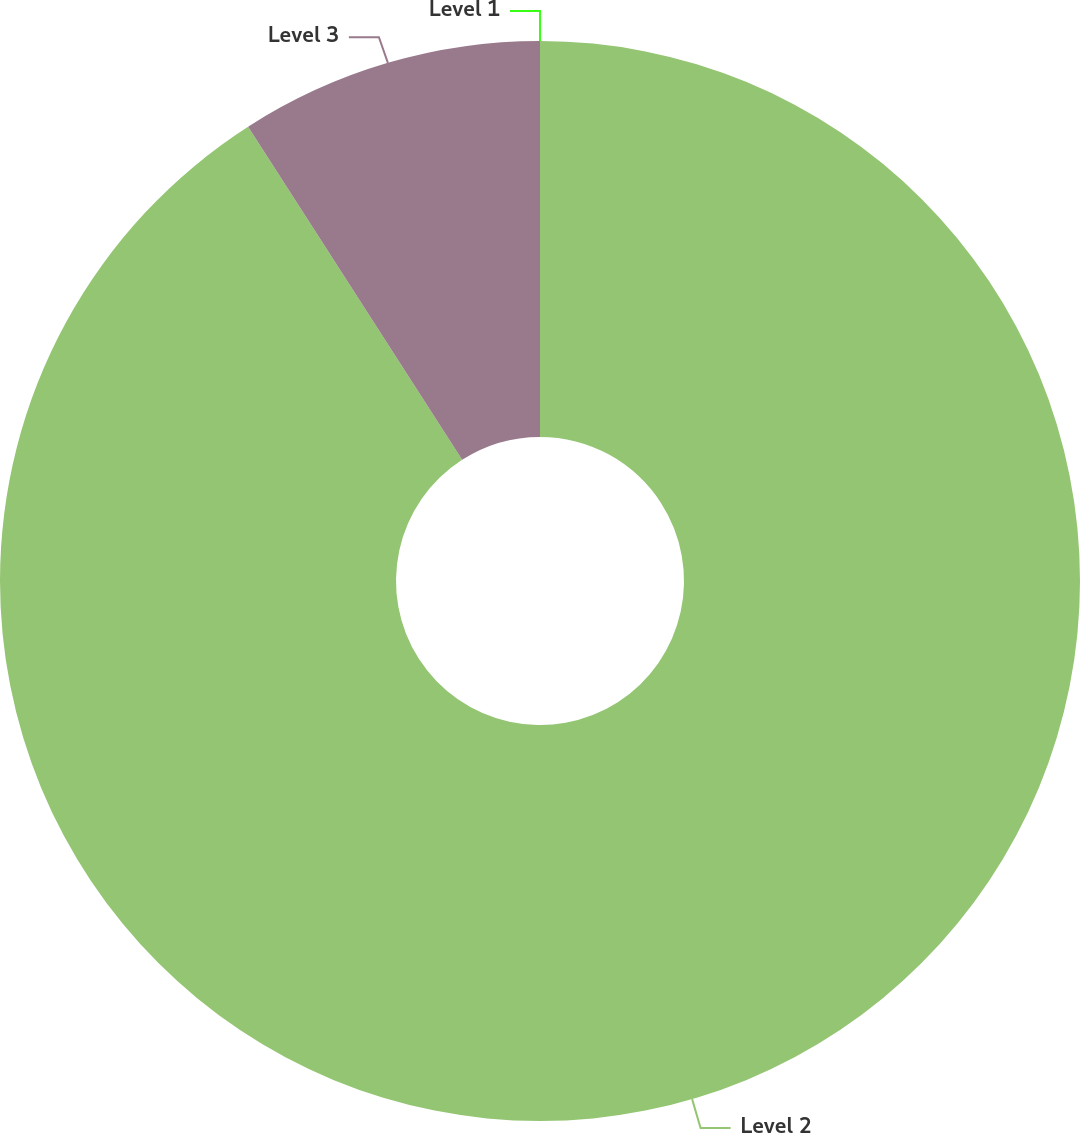<chart> <loc_0><loc_0><loc_500><loc_500><pie_chart><fcel>Level 1<fcel>Level 2<fcel>Level 3<nl><fcel>0.0%<fcel>90.91%<fcel>9.09%<nl></chart> 